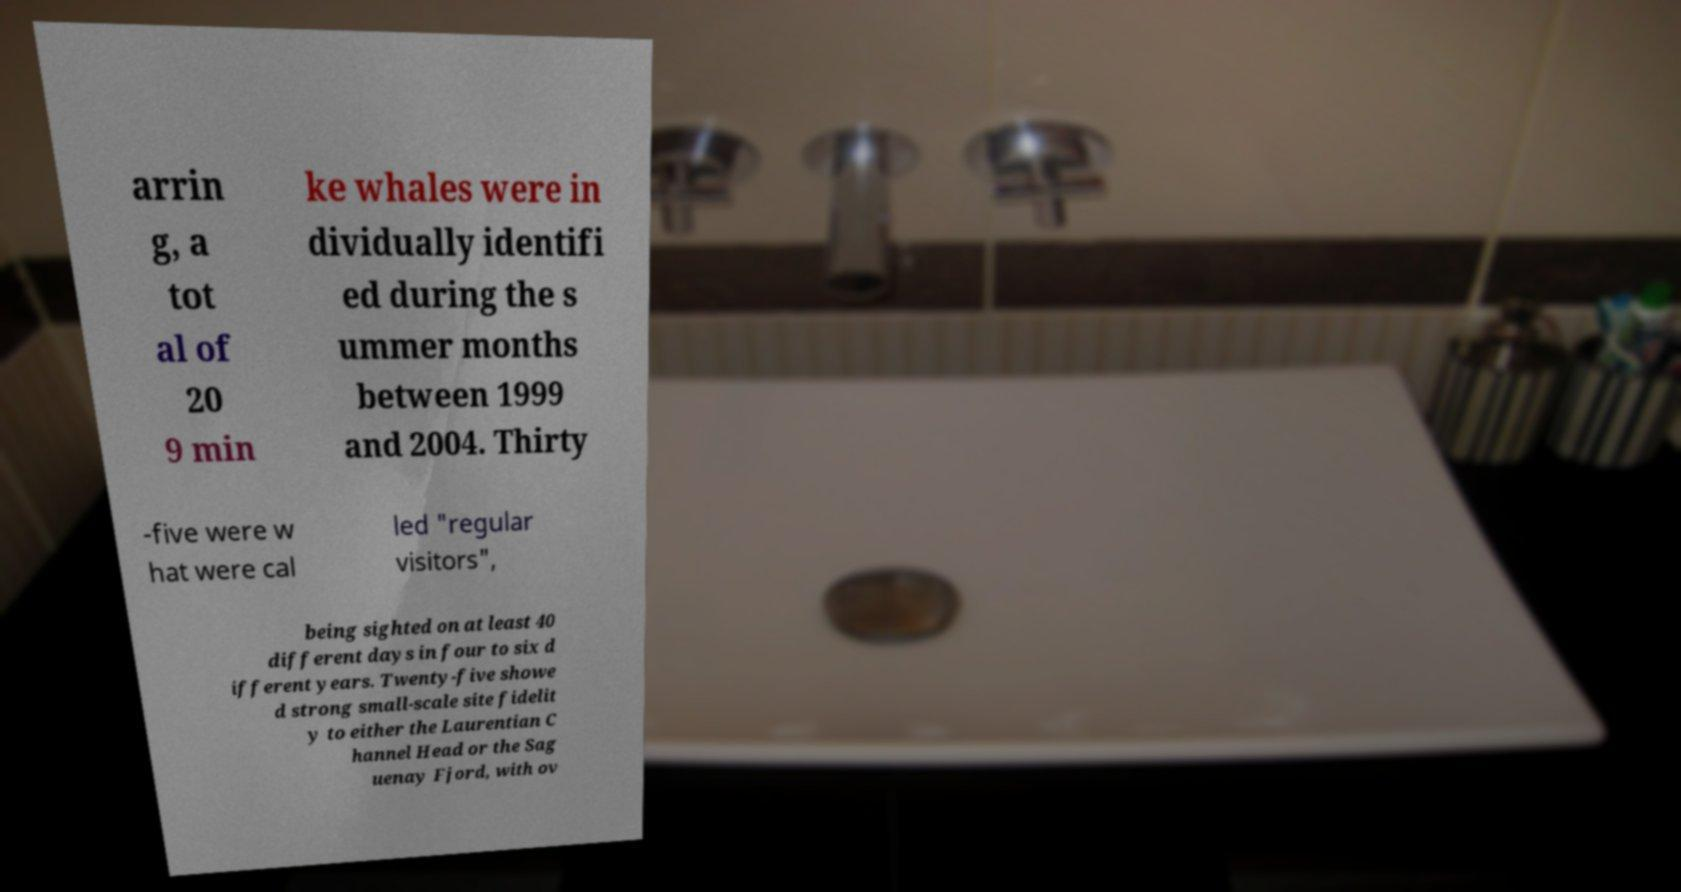Could you assist in decoding the text presented in this image and type it out clearly? arrin g, a tot al of 20 9 min ke whales were in dividually identifi ed during the s ummer months between 1999 and 2004. Thirty -five were w hat were cal led "regular visitors", being sighted on at least 40 different days in four to six d ifferent years. Twenty-five showe d strong small-scale site fidelit y to either the Laurentian C hannel Head or the Sag uenay Fjord, with ov 